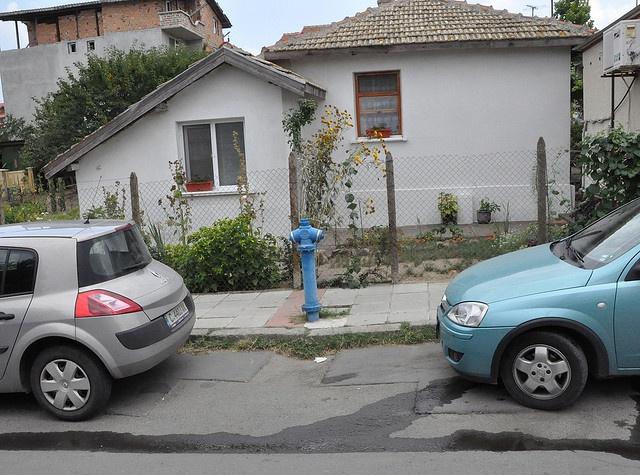Describe the objects in this image and their specific colors. I can see car in lavender, black, gray, darkgray, and lightgray tones, car in lavender, black, lightblue, gray, and darkgray tones, fire hydrant in lavender, gray, and blue tones, potted plant in lavender, gray, black, darkgray, and darkgreen tones, and potted plant in lavender, maroon, black, and brown tones in this image. 